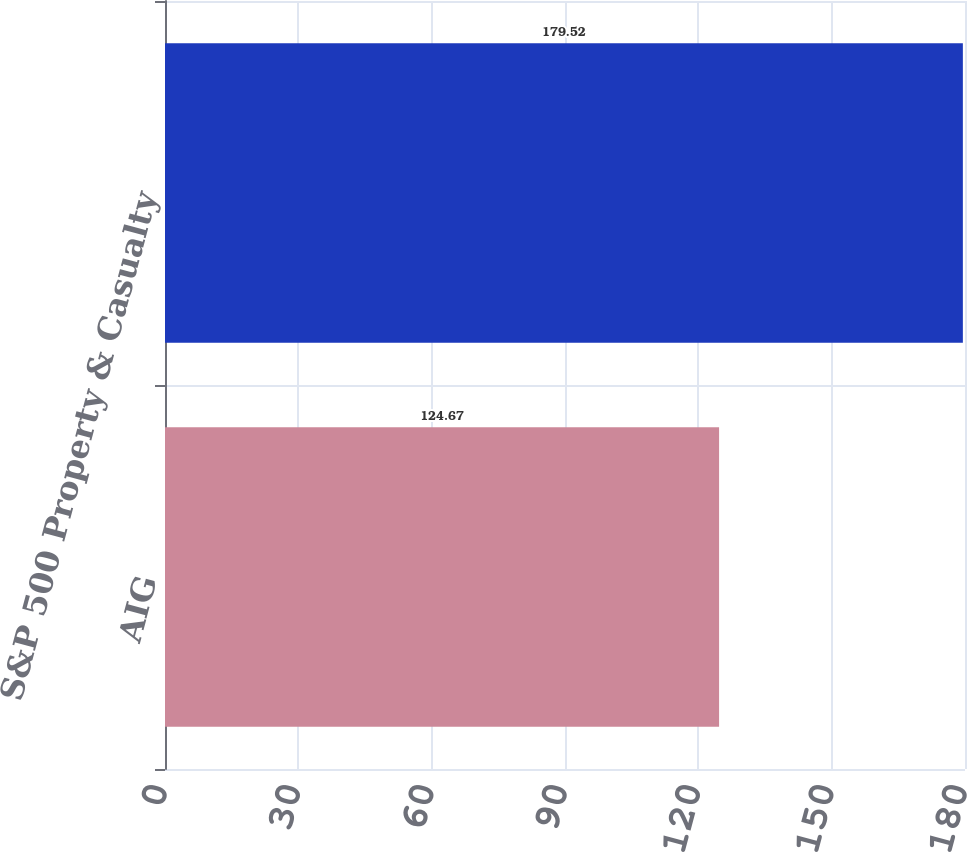Convert chart. <chart><loc_0><loc_0><loc_500><loc_500><bar_chart><fcel>AIG<fcel>S&P 500 Property & Casualty<nl><fcel>124.67<fcel>179.52<nl></chart> 